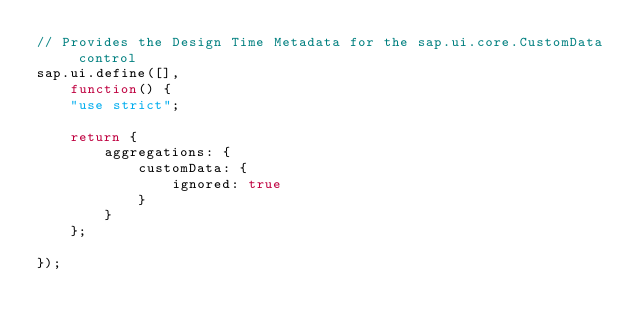Convert code to text. <code><loc_0><loc_0><loc_500><loc_500><_JavaScript_>// Provides the Design Time Metadata for the sap.ui.core.CustomData control
sap.ui.define([],
	function() {
	"use strict";

	return {
		aggregations: {
			customData: {
				ignored: true
			}
		}
	};

});</code> 